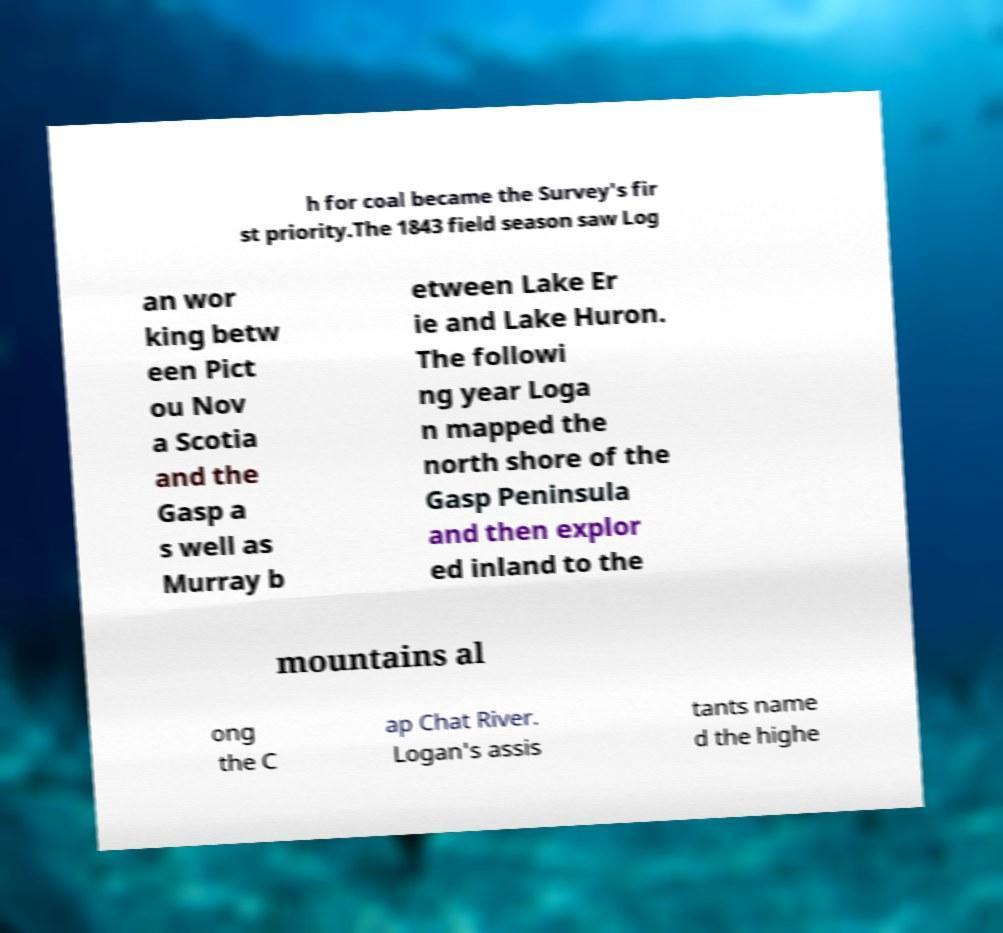Please identify and transcribe the text found in this image. h for coal became the Survey's fir st priority.The 1843 field season saw Log an wor king betw een Pict ou Nov a Scotia and the Gasp a s well as Murray b etween Lake Er ie and Lake Huron. The followi ng year Loga n mapped the north shore of the Gasp Peninsula and then explor ed inland to the mountains al ong the C ap Chat River. Logan's assis tants name d the highe 